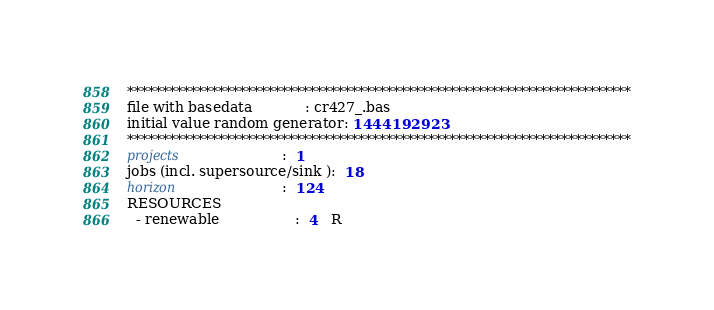Convert code to text. <code><loc_0><loc_0><loc_500><loc_500><_ObjectiveC_>************************************************************************
file with basedata            : cr427_.bas
initial value random generator: 1444192923
************************************************************************
projects                      :  1
jobs (incl. supersource/sink ):  18
horizon                       :  124
RESOURCES
  - renewable                 :  4   R</code> 